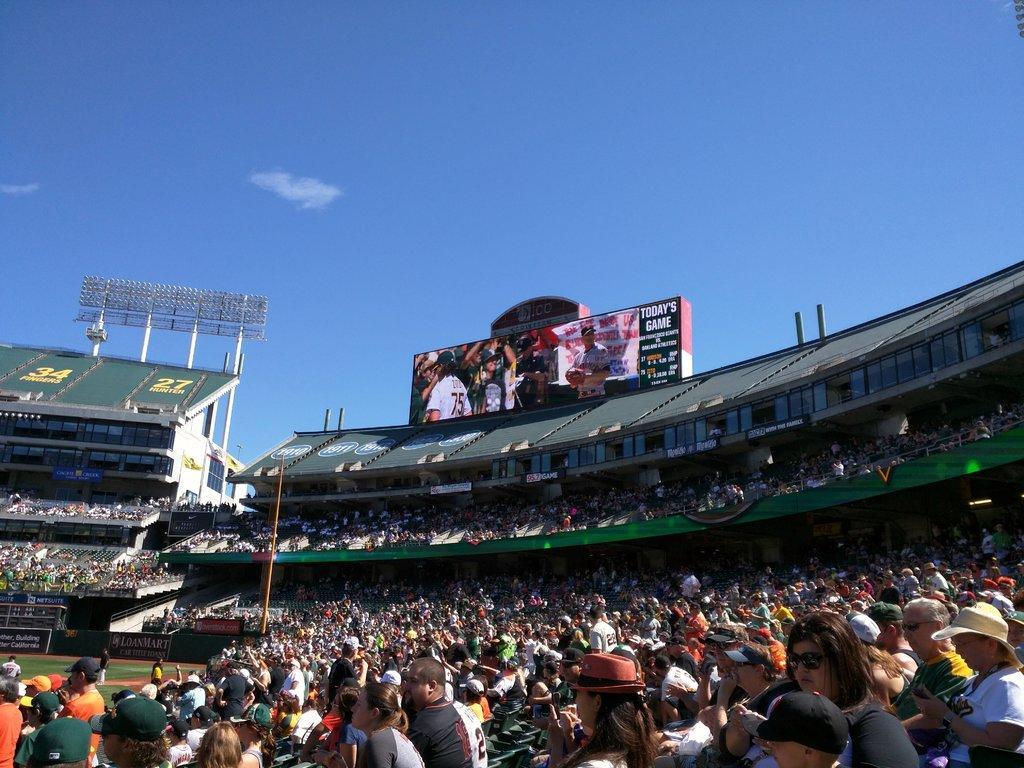Could you give a brief overview of what you see in this image? In this picture there are people and we can see ground, grass, stadium, poles, board, floodlights and hoardings. In the background of the image we can see the sky. 